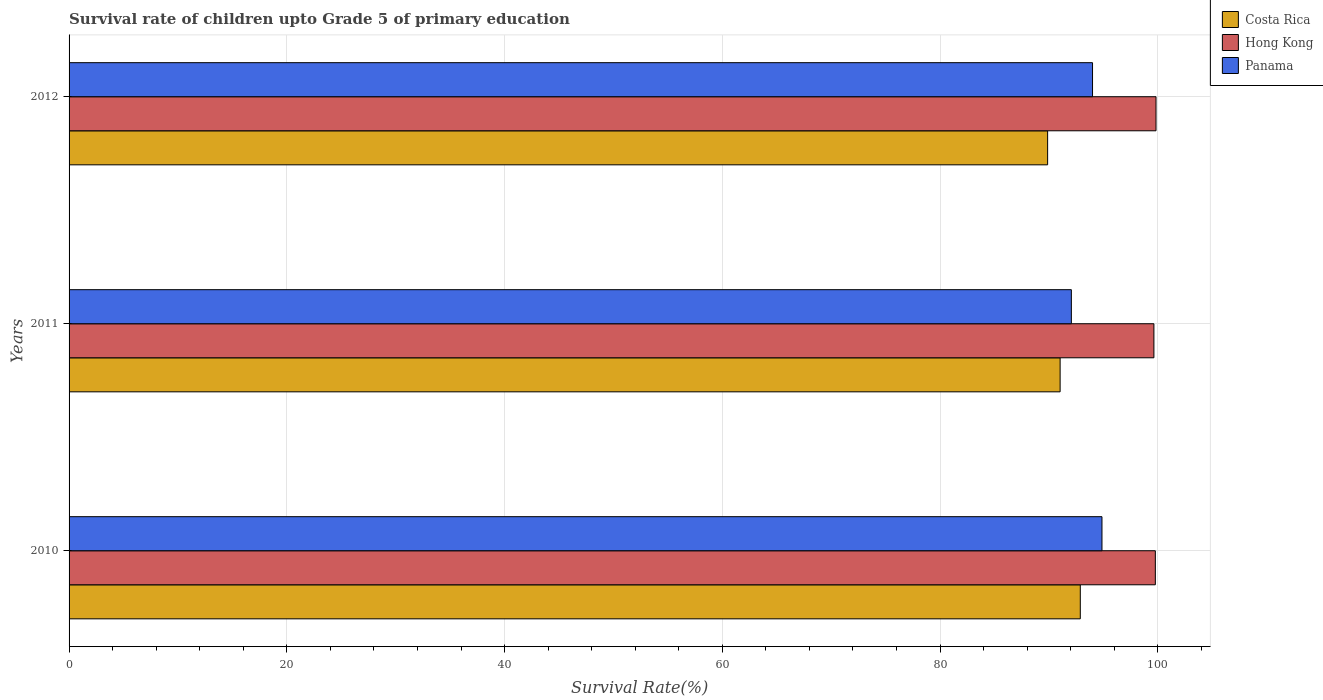How many different coloured bars are there?
Ensure brevity in your answer.  3. How many bars are there on the 1st tick from the top?
Ensure brevity in your answer.  3. What is the label of the 3rd group of bars from the top?
Give a very brief answer. 2010. What is the survival rate of children in Panama in 2011?
Ensure brevity in your answer.  92.06. Across all years, what is the maximum survival rate of children in Costa Rica?
Make the answer very short. 92.88. Across all years, what is the minimum survival rate of children in Hong Kong?
Your answer should be compact. 99.64. In which year was the survival rate of children in Panama maximum?
Your response must be concise. 2010. In which year was the survival rate of children in Panama minimum?
Provide a succinct answer. 2011. What is the total survival rate of children in Panama in the graph?
Ensure brevity in your answer.  280.94. What is the difference between the survival rate of children in Costa Rica in 2010 and that in 2011?
Offer a terse response. 1.85. What is the difference between the survival rate of children in Hong Kong in 2010 and the survival rate of children in Costa Rica in 2011?
Your answer should be very brief. 8.75. What is the average survival rate of children in Hong Kong per year?
Provide a short and direct response. 99.75. In the year 2011, what is the difference between the survival rate of children in Panama and survival rate of children in Hong Kong?
Your response must be concise. -7.58. In how many years, is the survival rate of children in Hong Kong greater than 32 %?
Keep it short and to the point. 3. What is the ratio of the survival rate of children in Costa Rica in 2010 to that in 2012?
Offer a very short reply. 1.03. Is the difference between the survival rate of children in Panama in 2010 and 2012 greater than the difference between the survival rate of children in Hong Kong in 2010 and 2012?
Give a very brief answer. Yes. What is the difference between the highest and the second highest survival rate of children in Costa Rica?
Your answer should be very brief. 1.85. What is the difference between the highest and the lowest survival rate of children in Costa Rica?
Make the answer very short. 3. In how many years, is the survival rate of children in Hong Kong greater than the average survival rate of children in Hong Kong taken over all years?
Your answer should be very brief. 2. What does the 2nd bar from the top in 2011 represents?
Make the answer very short. Hong Kong. What does the 3rd bar from the bottom in 2011 represents?
Provide a short and direct response. Panama. How many bars are there?
Your response must be concise. 9. How many years are there in the graph?
Your answer should be compact. 3. Does the graph contain any zero values?
Offer a very short reply. No. Where does the legend appear in the graph?
Give a very brief answer. Top right. How many legend labels are there?
Ensure brevity in your answer.  3. What is the title of the graph?
Ensure brevity in your answer.  Survival rate of children upto Grade 5 of primary education. Does "Zambia" appear as one of the legend labels in the graph?
Provide a short and direct response. No. What is the label or title of the X-axis?
Make the answer very short. Survival Rate(%). What is the Survival Rate(%) in Costa Rica in 2010?
Your response must be concise. 92.88. What is the Survival Rate(%) in Hong Kong in 2010?
Provide a short and direct response. 99.77. What is the Survival Rate(%) of Panama in 2010?
Offer a very short reply. 94.87. What is the Survival Rate(%) of Costa Rica in 2011?
Offer a very short reply. 91.03. What is the Survival Rate(%) in Hong Kong in 2011?
Offer a terse response. 99.64. What is the Survival Rate(%) in Panama in 2011?
Offer a very short reply. 92.06. What is the Survival Rate(%) of Costa Rica in 2012?
Ensure brevity in your answer.  89.88. What is the Survival Rate(%) in Hong Kong in 2012?
Give a very brief answer. 99.84. What is the Survival Rate(%) in Panama in 2012?
Ensure brevity in your answer.  94.01. Across all years, what is the maximum Survival Rate(%) of Costa Rica?
Your response must be concise. 92.88. Across all years, what is the maximum Survival Rate(%) in Hong Kong?
Offer a terse response. 99.84. Across all years, what is the maximum Survival Rate(%) in Panama?
Make the answer very short. 94.87. Across all years, what is the minimum Survival Rate(%) in Costa Rica?
Offer a very short reply. 89.88. Across all years, what is the minimum Survival Rate(%) in Hong Kong?
Your answer should be very brief. 99.64. Across all years, what is the minimum Survival Rate(%) of Panama?
Provide a short and direct response. 92.06. What is the total Survival Rate(%) of Costa Rica in the graph?
Keep it short and to the point. 273.79. What is the total Survival Rate(%) in Hong Kong in the graph?
Keep it short and to the point. 299.26. What is the total Survival Rate(%) in Panama in the graph?
Your answer should be compact. 280.94. What is the difference between the Survival Rate(%) in Costa Rica in 2010 and that in 2011?
Give a very brief answer. 1.85. What is the difference between the Survival Rate(%) in Hong Kong in 2010 and that in 2011?
Provide a succinct answer. 0.13. What is the difference between the Survival Rate(%) in Panama in 2010 and that in 2011?
Offer a terse response. 2.81. What is the difference between the Survival Rate(%) of Costa Rica in 2010 and that in 2012?
Make the answer very short. 3. What is the difference between the Survival Rate(%) of Hong Kong in 2010 and that in 2012?
Offer a very short reply. -0.06. What is the difference between the Survival Rate(%) of Panama in 2010 and that in 2012?
Offer a very short reply. 0.87. What is the difference between the Survival Rate(%) in Costa Rica in 2011 and that in 2012?
Offer a very short reply. 1.15. What is the difference between the Survival Rate(%) in Hong Kong in 2011 and that in 2012?
Ensure brevity in your answer.  -0.19. What is the difference between the Survival Rate(%) of Panama in 2011 and that in 2012?
Keep it short and to the point. -1.94. What is the difference between the Survival Rate(%) in Costa Rica in 2010 and the Survival Rate(%) in Hong Kong in 2011?
Offer a terse response. -6.76. What is the difference between the Survival Rate(%) in Costa Rica in 2010 and the Survival Rate(%) in Panama in 2011?
Provide a short and direct response. 0.82. What is the difference between the Survival Rate(%) of Hong Kong in 2010 and the Survival Rate(%) of Panama in 2011?
Offer a very short reply. 7.71. What is the difference between the Survival Rate(%) of Costa Rica in 2010 and the Survival Rate(%) of Hong Kong in 2012?
Offer a very short reply. -6.96. What is the difference between the Survival Rate(%) in Costa Rica in 2010 and the Survival Rate(%) in Panama in 2012?
Your answer should be compact. -1.12. What is the difference between the Survival Rate(%) of Hong Kong in 2010 and the Survival Rate(%) of Panama in 2012?
Provide a short and direct response. 5.77. What is the difference between the Survival Rate(%) in Costa Rica in 2011 and the Survival Rate(%) in Hong Kong in 2012?
Keep it short and to the point. -8.81. What is the difference between the Survival Rate(%) of Costa Rica in 2011 and the Survival Rate(%) of Panama in 2012?
Provide a succinct answer. -2.98. What is the difference between the Survival Rate(%) of Hong Kong in 2011 and the Survival Rate(%) of Panama in 2012?
Offer a very short reply. 5.64. What is the average Survival Rate(%) in Costa Rica per year?
Keep it short and to the point. 91.26. What is the average Survival Rate(%) in Hong Kong per year?
Your answer should be very brief. 99.75. What is the average Survival Rate(%) of Panama per year?
Make the answer very short. 93.65. In the year 2010, what is the difference between the Survival Rate(%) in Costa Rica and Survival Rate(%) in Hong Kong?
Your response must be concise. -6.89. In the year 2010, what is the difference between the Survival Rate(%) of Costa Rica and Survival Rate(%) of Panama?
Keep it short and to the point. -1.99. In the year 2010, what is the difference between the Survival Rate(%) of Hong Kong and Survival Rate(%) of Panama?
Offer a terse response. 4.9. In the year 2011, what is the difference between the Survival Rate(%) in Costa Rica and Survival Rate(%) in Hong Kong?
Make the answer very short. -8.61. In the year 2011, what is the difference between the Survival Rate(%) in Costa Rica and Survival Rate(%) in Panama?
Provide a succinct answer. -1.03. In the year 2011, what is the difference between the Survival Rate(%) of Hong Kong and Survival Rate(%) of Panama?
Keep it short and to the point. 7.58. In the year 2012, what is the difference between the Survival Rate(%) in Costa Rica and Survival Rate(%) in Hong Kong?
Provide a short and direct response. -9.96. In the year 2012, what is the difference between the Survival Rate(%) of Costa Rica and Survival Rate(%) of Panama?
Keep it short and to the point. -4.12. In the year 2012, what is the difference between the Survival Rate(%) of Hong Kong and Survival Rate(%) of Panama?
Keep it short and to the point. 5.83. What is the ratio of the Survival Rate(%) of Costa Rica in 2010 to that in 2011?
Offer a very short reply. 1.02. What is the ratio of the Survival Rate(%) in Hong Kong in 2010 to that in 2011?
Make the answer very short. 1. What is the ratio of the Survival Rate(%) in Panama in 2010 to that in 2011?
Your response must be concise. 1.03. What is the ratio of the Survival Rate(%) in Costa Rica in 2010 to that in 2012?
Keep it short and to the point. 1.03. What is the ratio of the Survival Rate(%) of Panama in 2010 to that in 2012?
Give a very brief answer. 1.01. What is the ratio of the Survival Rate(%) of Costa Rica in 2011 to that in 2012?
Offer a terse response. 1.01. What is the ratio of the Survival Rate(%) in Panama in 2011 to that in 2012?
Your answer should be very brief. 0.98. What is the difference between the highest and the second highest Survival Rate(%) in Costa Rica?
Your answer should be very brief. 1.85. What is the difference between the highest and the second highest Survival Rate(%) in Hong Kong?
Offer a very short reply. 0.06. What is the difference between the highest and the second highest Survival Rate(%) in Panama?
Ensure brevity in your answer.  0.87. What is the difference between the highest and the lowest Survival Rate(%) of Costa Rica?
Your answer should be compact. 3. What is the difference between the highest and the lowest Survival Rate(%) of Hong Kong?
Ensure brevity in your answer.  0.19. What is the difference between the highest and the lowest Survival Rate(%) of Panama?
Offer a very short reply. 2.81. 